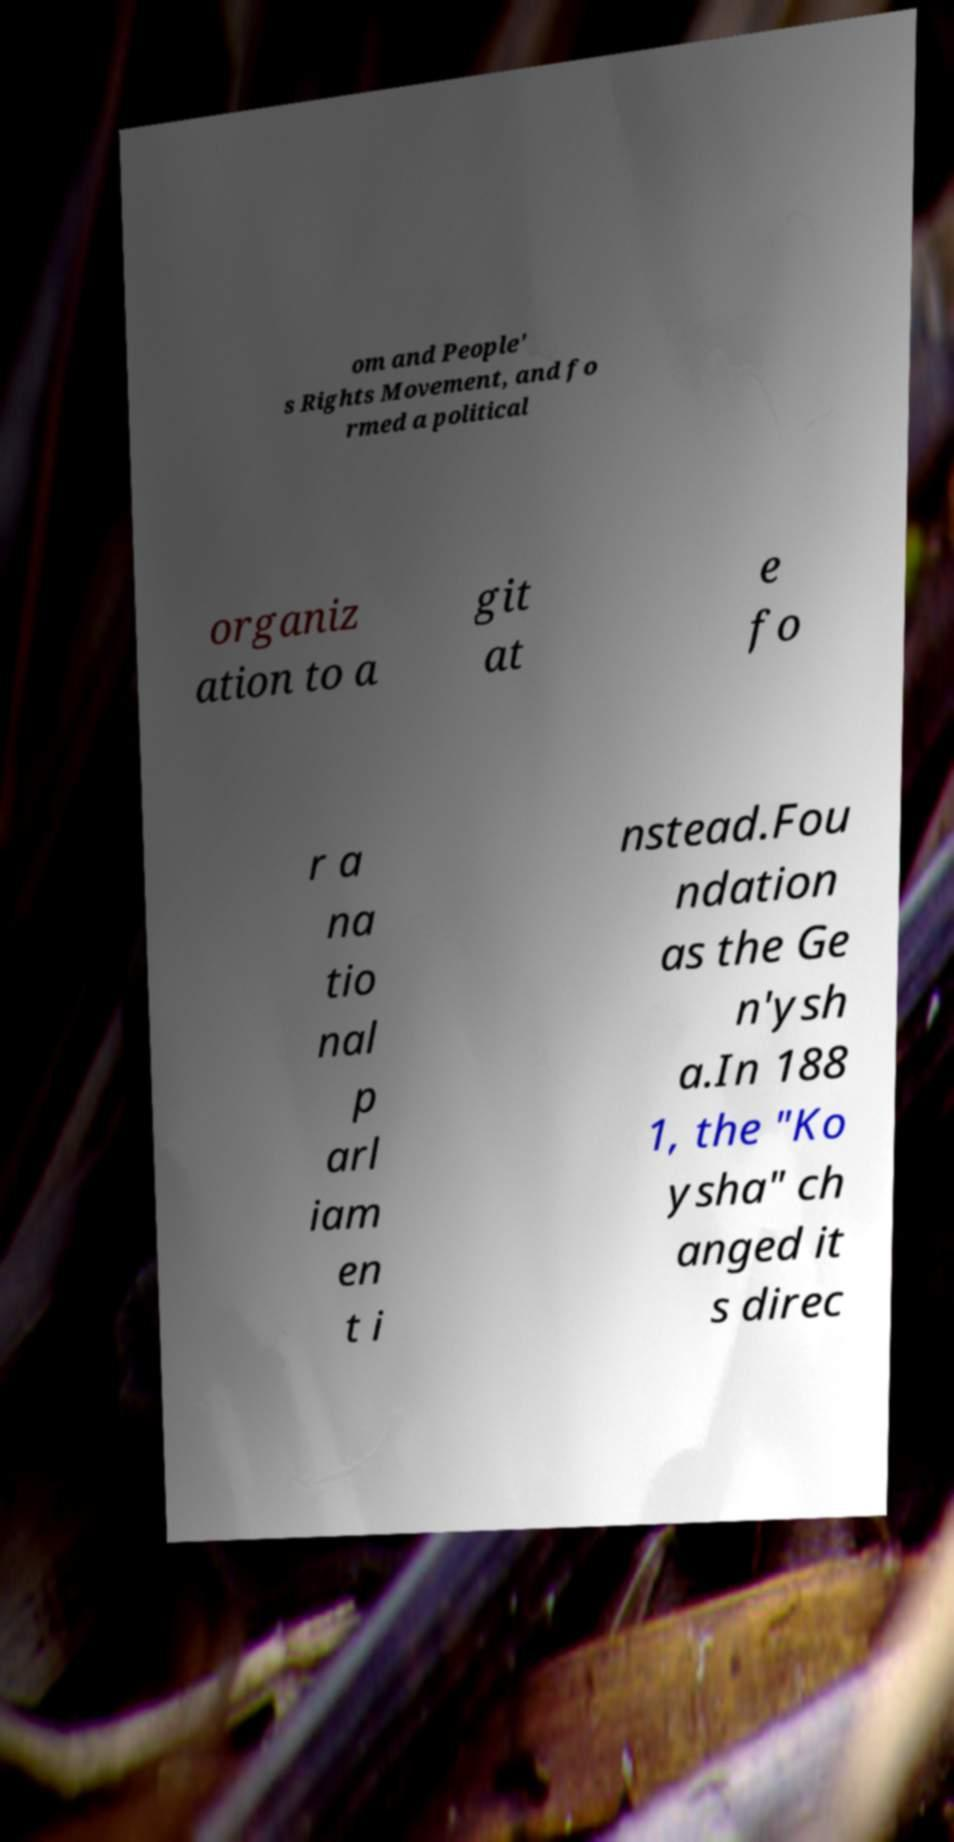Can you accurately transcribe the text from the provided image for me? om and People' s Rights Movement, and fo rmed a political organiz ation to a git at e fo r a na tio nal p arl iam en t i nstead.Fou ndation as the Ge n'ysh a.In 188 1, the "Ko ysha" ch anged it s direc 